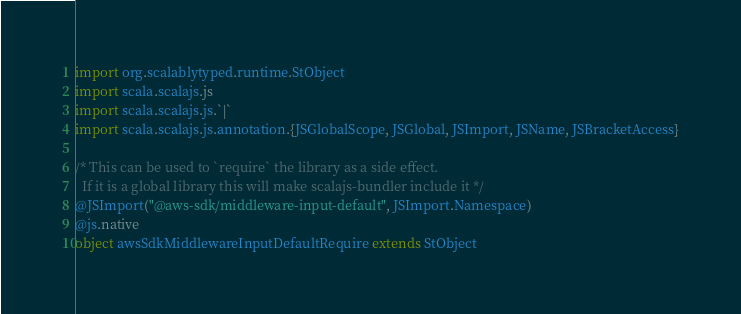Convert code to text. <code><loc_0><loc_0><loc_500><loc_500><_Scala_>
import org.scalablytyped.runtime.StObject
import scala.scalajs.js
import scala.scalajs.js.`|`
import scala.scalajs.js.annotation.{JSGlobalScope, JSGlobal, JSImport, JSName, JSBracketAccess}

/* This can be used to `require` the library as a side effect.
  If it is a global library this will make scalajs-bundler include it */
@JSImport("@aws-sdk/middleware-input-default", JSImport.Namespace)
@js.native
object awsSdkMiddlewareInputDefaultRequire extends StObject
</code> 